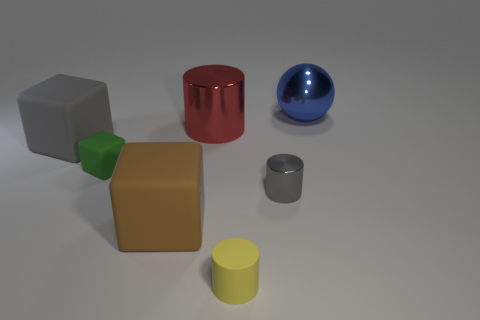Is the number of red cylinders greater than the number of big blocks?
Your answer should be compact. No. Is there anything else of the same color as the small shiny cylinder?
Provide a succinct answer. Yes. Does the big sphere have the same material as the big cylinder?
Your answer should be very brief. Yes. Are there fewer large matte objects than cylinders?
Keep it short and to the point. Yes. Does the red thing have the same shape as the tiny yellow rubber thing?
Provide a short and direct response. Yes. The tiny matte cube is what color?
Offer a terse response. Green. How many other things are the same material as the brown cube?
Provide a succinct answer. 3. How many red things are either rubber objects or large balls?
Your response must be concise. 0. Do the shiny thing that is on the left side of the yellow matte cylinder and the big matte thing behind the large brown cube have the same shape?
Your answer should be very brief. No. Does the tiny shiny cylinder have the same color as the large matte block behind the brown matte cube?
Provide a succinct answer. Yes. 